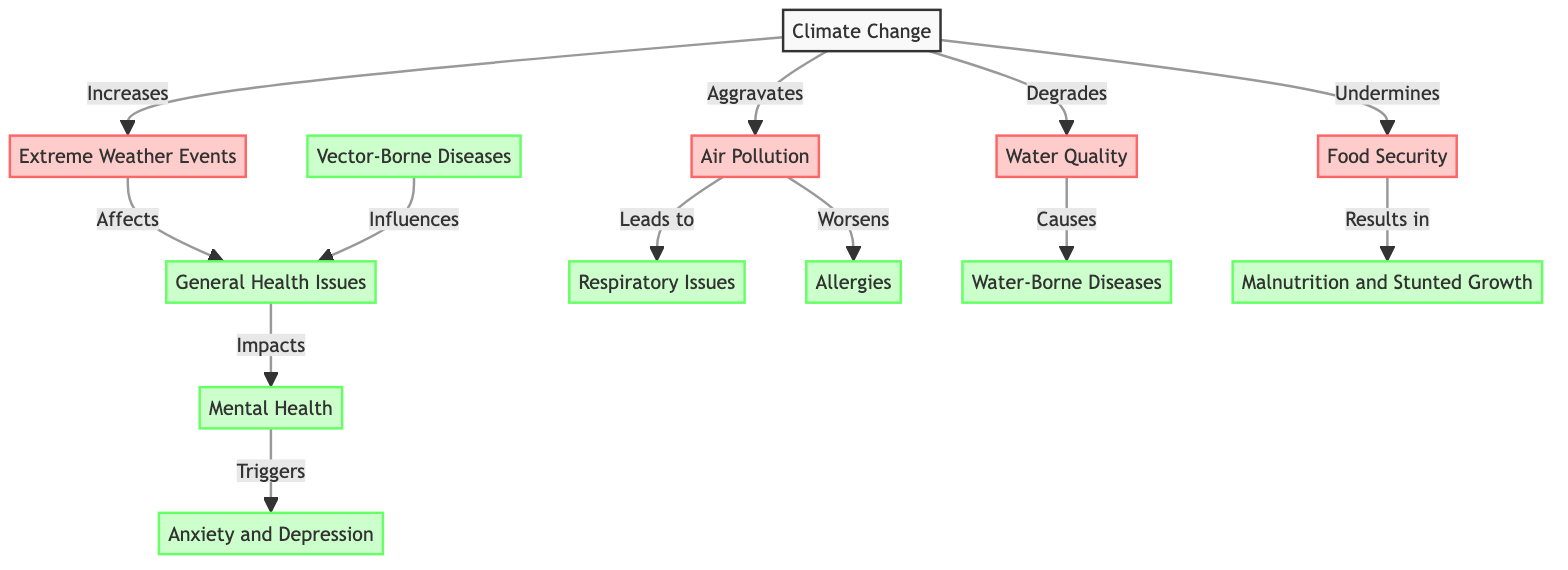What is the primary cause of extreme weather events in the diagram? The diagram indicates that climate change is the primary cause leading to an increase in extreme weather events. The arrow from "Climate Change" to "Extreme Weather Events" denotes this direct relationship.
Answer: Climate Change How many health issues are depicted as effects of climate change? In the diagram, there are six health issues listed as effects of climate change. By counting the nodes under the "effect" category, we find respiratory issues, allergies, vector-borne diseases, water-borne diseases, malnutrition and stunted growth, and anxiety and depression, totaling six.
Answer: 6 Which factor leads to respiratory issues? The diagram shows that air pollution leads to respiratory issues, as indicated by the arrow connecting the two nodes with the label "Leads to." Hence, to identify the cause of respiratory issues, one would look at the "Air Pollution" node, which connects to it directly.
Answer: Air Pollution What relationship does food security have with malnutrition? The diagram indicates that food security results in malnutrition, as shown by the arrow from "Food Security" pointing to "Malnutrition and Stunted Growth," labeled "Results in." This implies that challenges in food security directly affect nutritional outcomes.
Answer: Results in How does general health impact mental health? The diagram outlines that general health affects mental health. The connection is shown with an arrow from "General Health Issues" to "Mental Health," suggesting that issues in general health can have a negative effect on mental health, indicating a direct relation between the two.
Answer: Impacts What is aggravated by climate change according to the diagram? The diagram specifies that air pollution is aggravated by climate change, as depicted by the arrow labeled "Aggravates" originating from "Climate Change" and pointing towards "Air Pollution." This suggests that the effects of climate change contribute to worsening air quality.
Answer: Air Pollution Which issue is directly connected to both water quality and water-borne diseases? The relationship demonstrates that water quality directly causes water-borne diseases, as indicated by the arrow from "Water Quality" to "Water-Borne Diseases," labeled "Causes." This illustrates a clear causative connection between the quality of water and the incidence of related diseases.
Answer: Causes What effect does anxiety and depression have in relation to mental health? The diagram illustrates that anxiety and depression are triggered by mental health issues. The arrow from "Mental Health" to "Anxiety and Depression" indicates that poor mental health can lead to increasing levels of anxiety and depression in children.
Answer: Triggers 